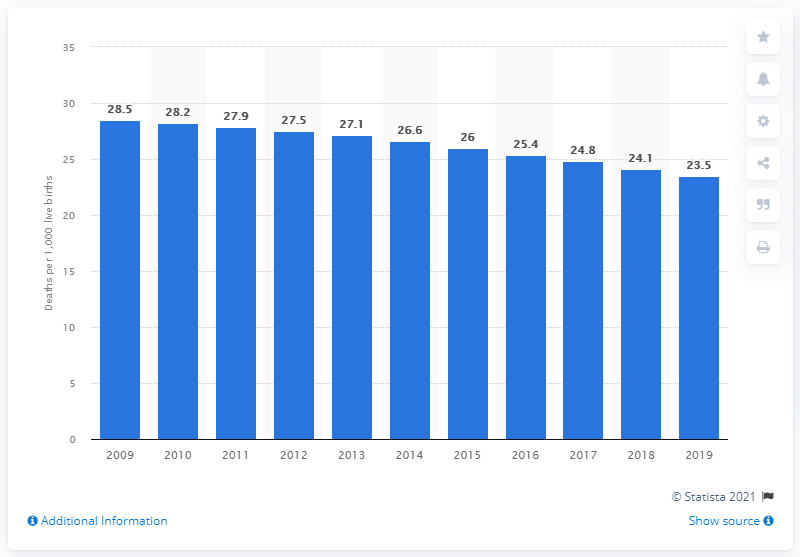Outline some significant characteristics in this image. In 2019, the infant mortality rate in the Dominican Republic was 23.5 deaths per 1,000 live births. 